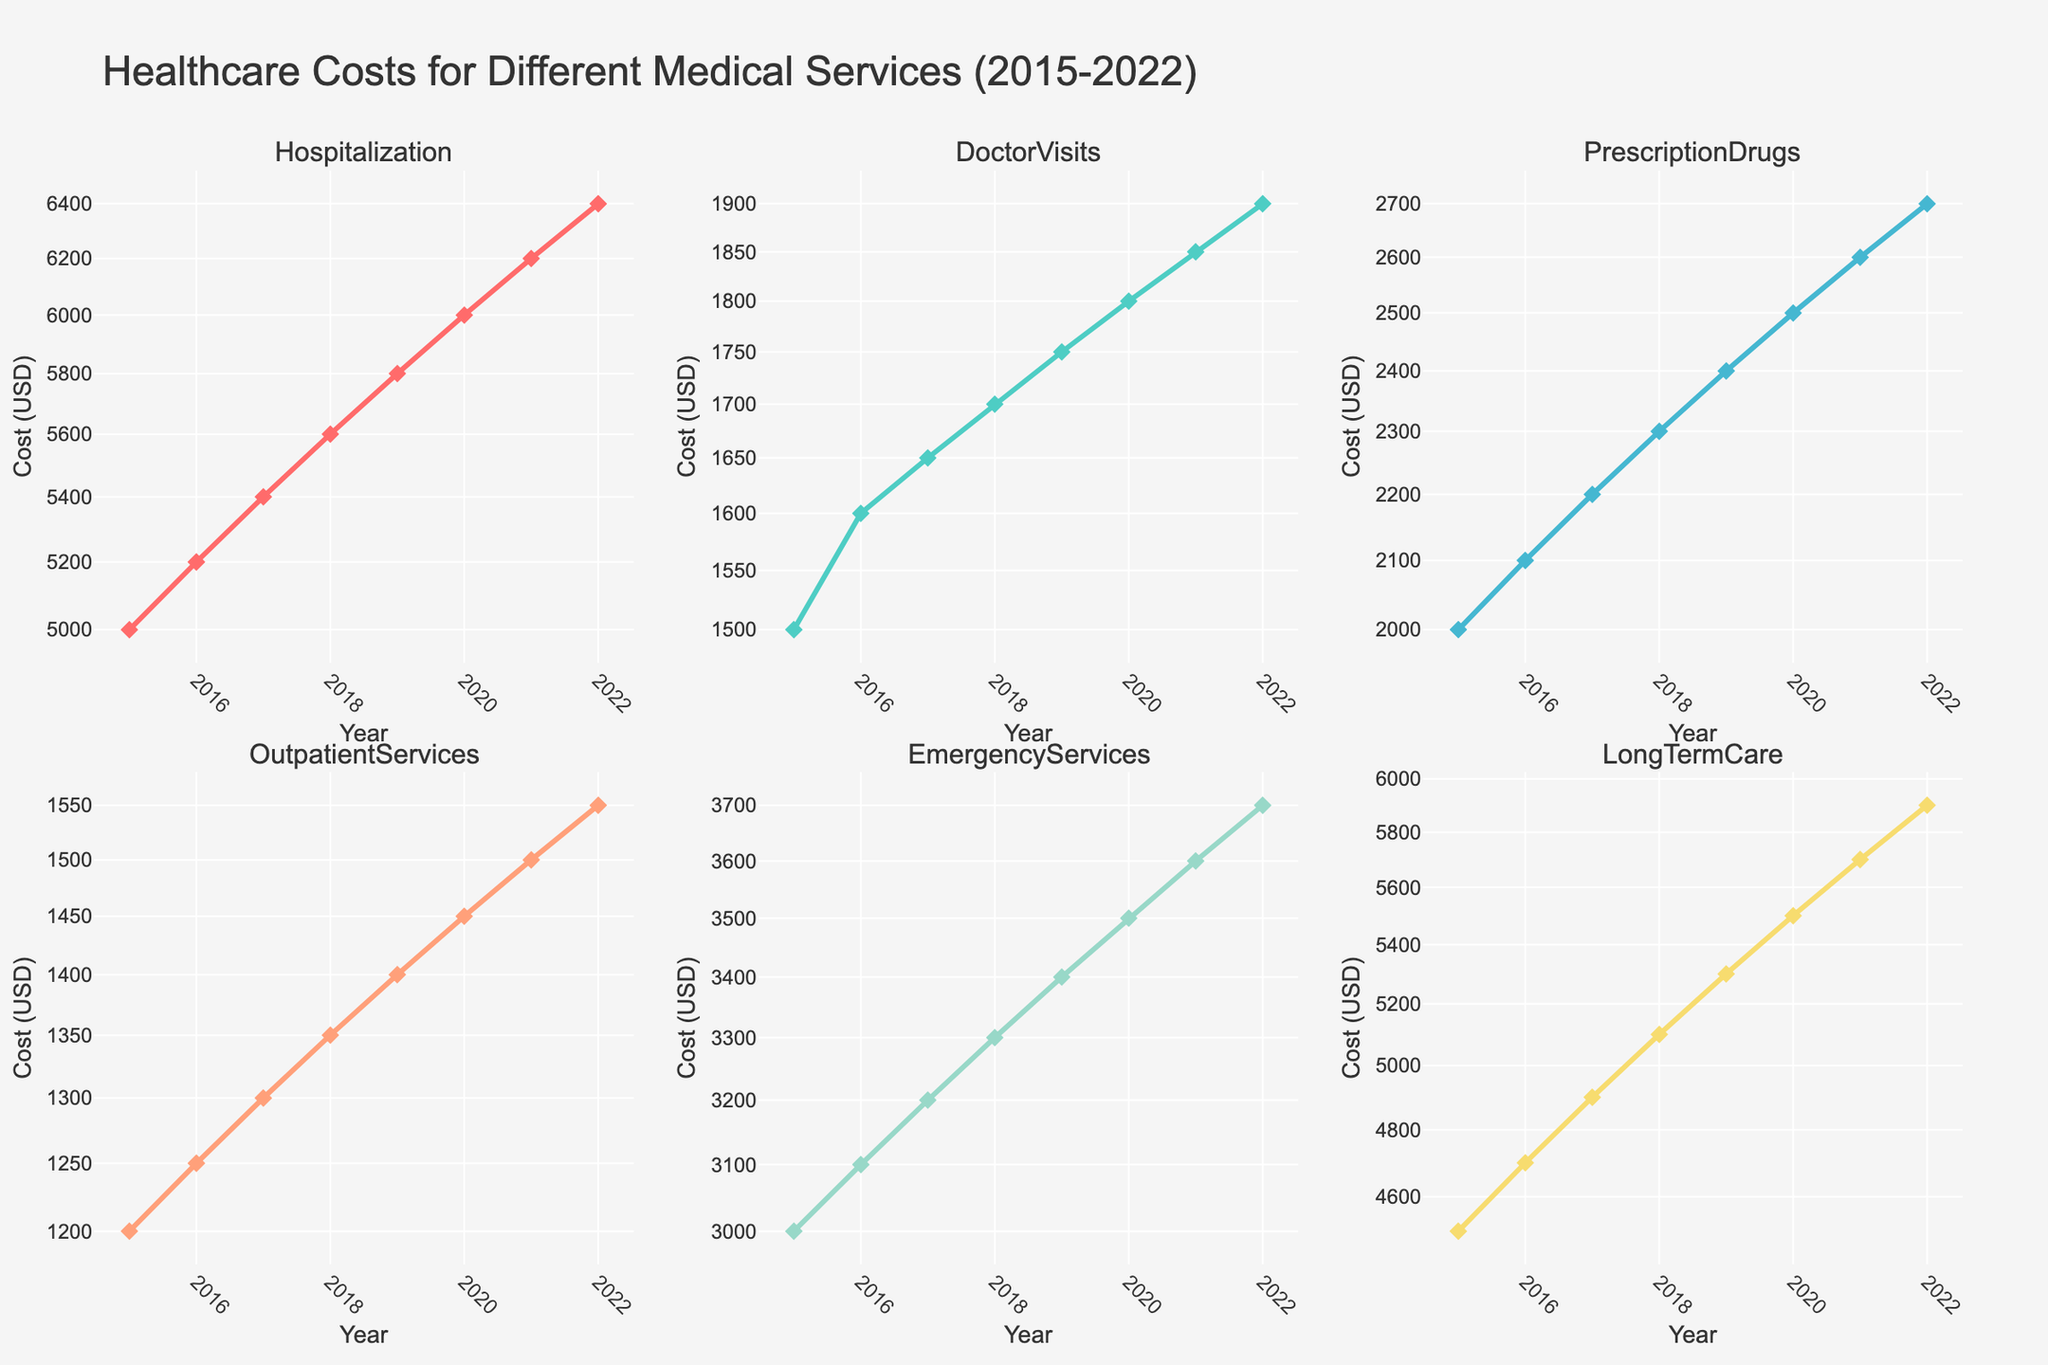What is the title of the figure? The title of the figure is prominently displayed at the top of the screen. It helps provide context about what the figure represents. In this case, the title is "Healthcare Costs for Different Medical Services (2015-2022)."
Answer: Healthcare Costs for Different Medical Services (2015-2022) Which medical service has the highest healthcare costs in 2022? To determine which medical service has the highest healthcare costs in 2022, look for the data point representing 2022 on each subplot and identify the highest value among them. LongTermCare has the highest cost.
Answer: LongTermCare How have the costs for Doctor Visits changed from 2015 to 2022? Look at the subplot for Doctor Visits and observe the trend line from 2015 to 2022. The costs increase gradually over time, starting from 1500 USD in 2015 to 1900 USD in 2022.
Answer: Increased from 1500 USD to 1900 USD For which medical service did costs increase by 500 USD from 2019 to 2022? To identify the service, check the differences in cost from 2019 to 2022 in each subplot. LongTermCare shows an increase from 5300 USD in 2019 to 5900 USD in 2022, which is an increase of 600 USD, close to 500 USD.
Answer: LongTermCare How does the cost trend for Prescription Drugs compare to Outpatient Services over the range of years? Examine the subplots for both Prescription Drugs and Outpatient Services. While both costs increase over time, Prescription Drugs outpaces Outpatient Services, which shows a more modest rise.
Answer: Prescription Drugs increased at a higher rate What is the log scale difference in costs between Hospitalization and Emergency Services in 2020? Since the data is on a log scale, calculate the logarithmic difference. Hospitalization is 6000 USD and Emergency Services is 3500 USD. Logarithmically, this is a difference of log10(6000) - log10(3500).
Answer: Approximately 0.24 Which service had its costs reach exactly 2500 USD in 2020? Look for the data point representing 2020 and see which medical service cost is exactly 2500 USD. In this case, Prescription Drugs have a cost of 2500 USD in 2020.
Answer: PrescriptionDrugs What is the visual difference between the subplots concerning y-axis scaling? Every subplot has its y-axis in logarithmic scale, which helps in showing the relative differences more clearly, especially when there are large variances in data values.
Answer: Logarithmic y-axis Which medical service shows the least fluctuation in costs over the years? The service with the least fluctuation can be identified by examining the variance in the trend lines. Doctor Visits have a relatively steady increase without much fluctuation.
Answer: DoctorVisits What year sees the largest increase in costs for Emergency Services? By inspecting the trend line for Emergency Services, the largest year-to-year jump can be identified. The jump from 2016 to 2017 appears to be the largest.
Answer: 2016 to 2017 